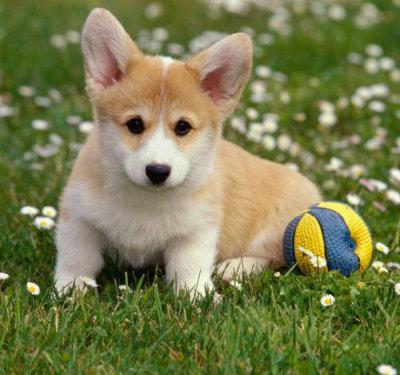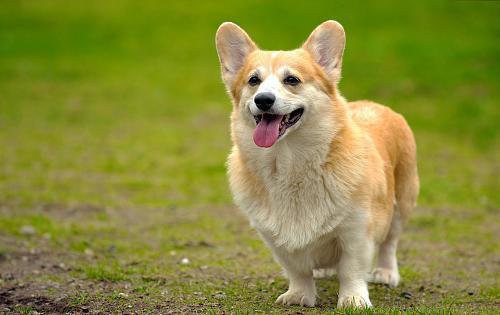The first image is the image on the left, the second image is the image on the right. Analyze the images presented: Is the assertion "One image shows a grinning, close-mouthed corgi with ears that splay outward, sitting upright in grass." valid? Answer yes or no. No. The first image is the image on the left, the second image is the image on the right. Assess this claim about the two images: "There is one corgi sitting in the grass outside and another corgi who is standing in the grass while outside.". Correct or not? Answer yes or no. Yes. 